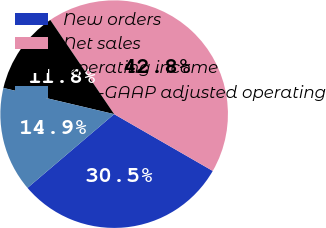Convert chart. <chart><loc_0><loc_0><loc_500><loc_500><pie_chart><fcel>New orders<fcel>Net sales<fcel>Operating income<fcel>Non-GAAP adjusted operating<nl><fcel>30.46%<fcel>42.8%<fcel>11.82%<fcel>14.92%<nl></chart> 